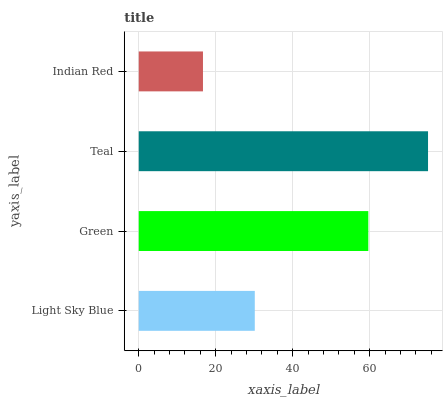Is Indian Red the minimum?
Answer yes or no. Yes. Is Teal the maximum?
Answer yes or no. Yes. Is Green the minimum?
Answer yes or no. No. Is Green the maximum?
Answer yes or no. No. Is Green greater than Light Sky Blue?
Answer yes or no. Yes. Is Light Sky Blue less than Green?
Answer yes or no. Yes. Is Light Sky Blue greater than Green?
Answer yes or no. No. Is Green less than Light Sky Blue?
Answer yes or no. No. Is Green the high median?
Answer yes or no. Yes. Is Light Sky Blue the low median?
Answer yes or no. Yes. Is Light Sky Blue the high median?
Answer yes or no. No. Is Indian Red the low median?
Answer yes or no. No. 